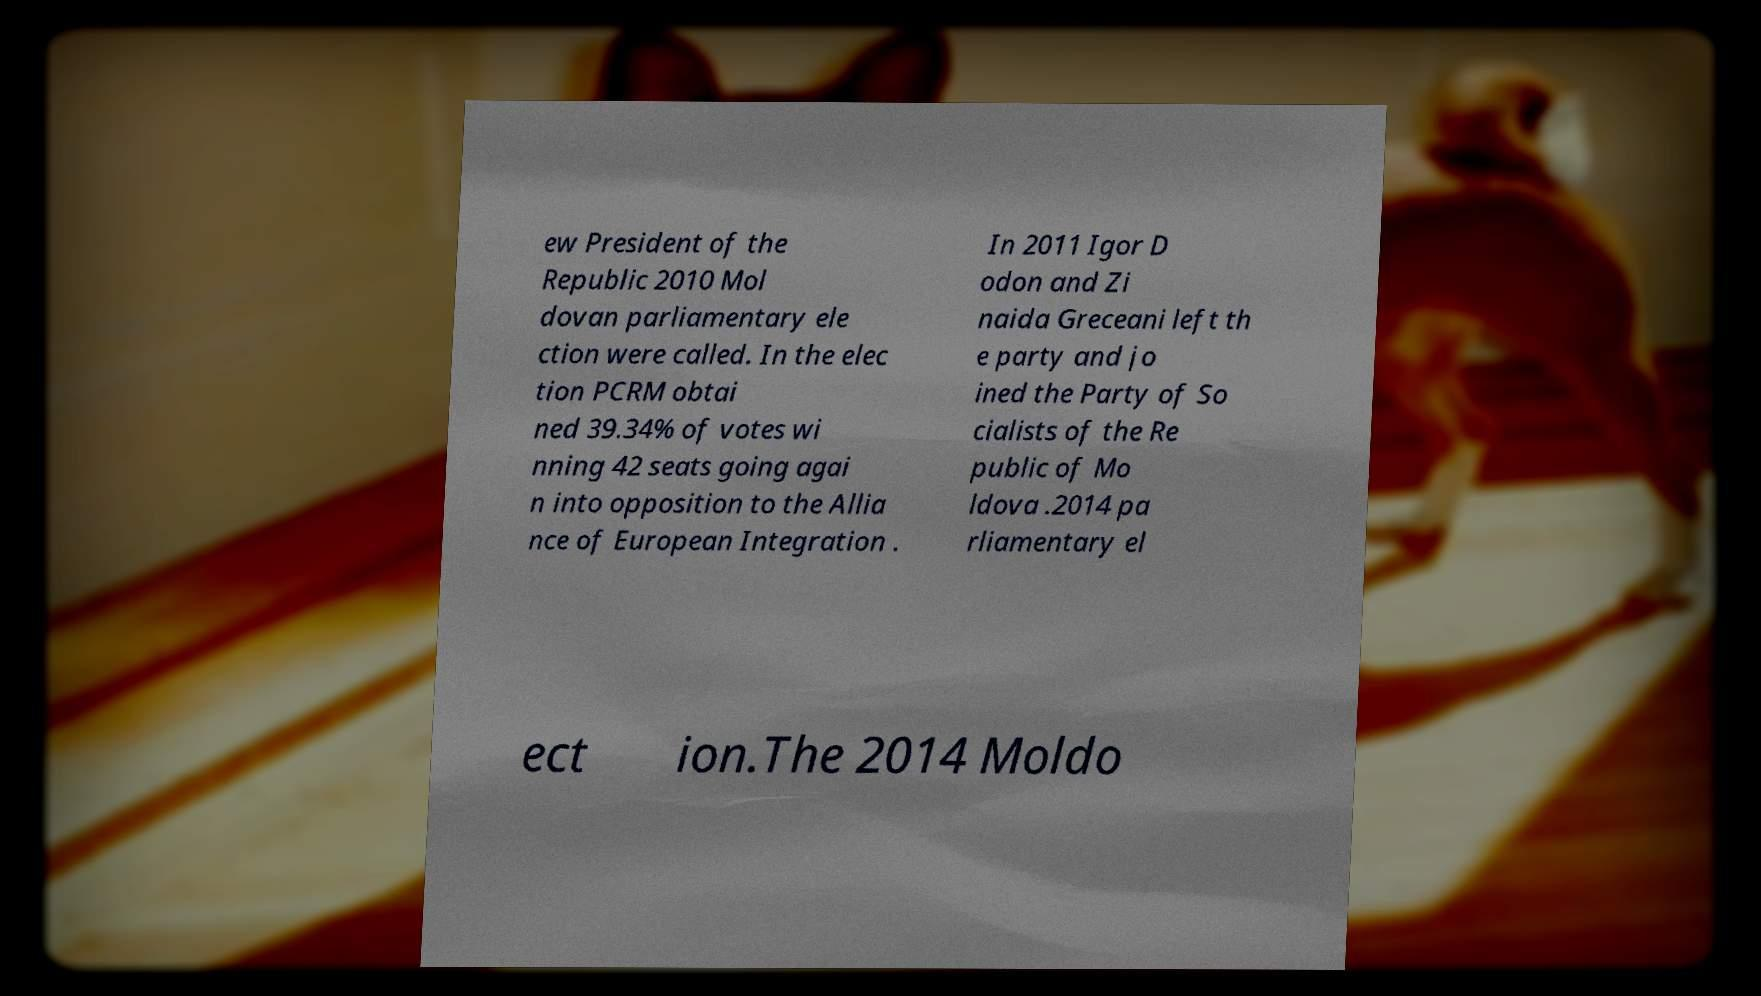What messages or text are displayed in this image? I need them in a readable, typed format. ew President of the Republic 2010 Mol dovan parliamentary ele ction were called. In the elec tion PCRM obtai ned 39.34% of votes wi nning 42 seats going agai n into opposition to the Allia nce of European Integration . In 2011 Igor D odon and Zi naida Greceani left th e party and jo ined the Party of So cialists of the Re public of Mo ldova .2014 pa rliamentary el ect ion.The 2014 Moldo 